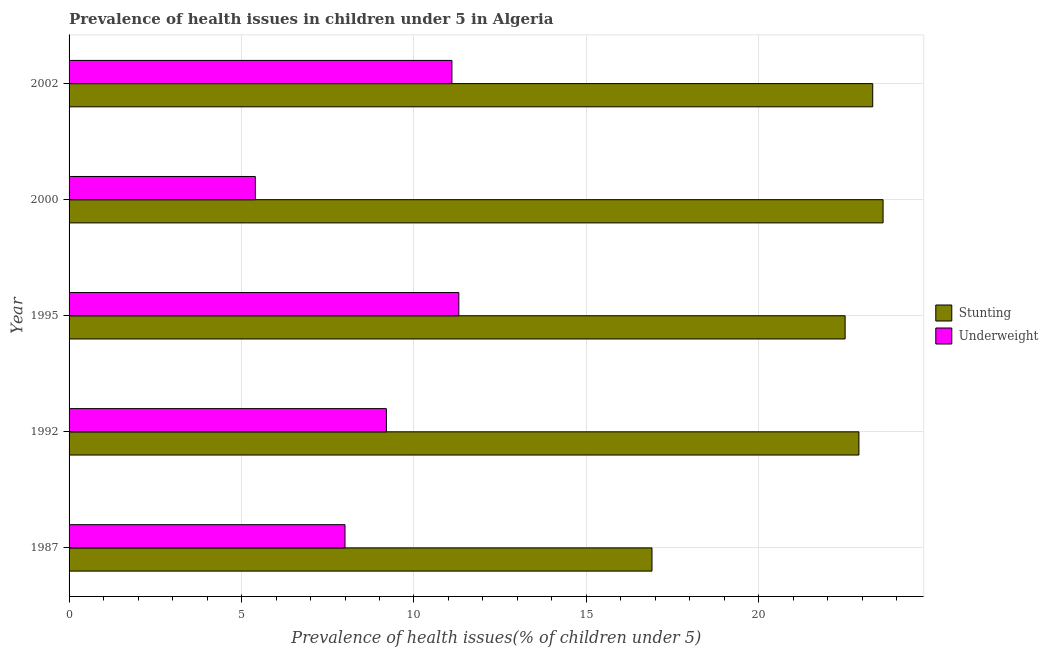How many groups of bars are there?
Keep it short and to the point. 5. Are the number of bars on each tick of the Y-axis equal?
Ensure brevity in your answer.  Yes. How many bars are there on the 1st tick from the top?
Provide a short and direct response. 2. How many bars are there on the 2nd tick from the bottom?
Ensure brevity in your answer.  2. What is the label of the 2nd group of bars from the top?
Your response must be concise. 2000. What is the percentage of stunted children in 2002?
Provide a succinct answer. 23.3. Across all years, what is the maximum percentage of underweight children?
Provide a short and direct response. 11.3. Across all years, what is the minimum percentage of stunted children?
Ensure brevity in your answer.  16.9. In which year was the percentage of stunted children maximum?
Your answer should be very brief. 2000. In which year was the percentage of stunted children minimum?
Provide a succinct answer. 1987. What is the total percentage of underweight children in the graph?
Provide a short and direct response. 45. What is the difference between the percentage of underweight children in 1992 and the percentage of stunted children in 2002?
Offer a very short reply. -14.1. What is the average percentage of underweight children per year?
Your answer should be compact. 9. What is the ratio of the percentage of stunted children in 1987 to that in 2002?
Offer a terse response. 0.72. Is the percentage of underweight children in 1995 less than that in 2002?
Your answer should be compact. No. Is the difference between the percentage of underweight children in 1995 and 2000 greater than the difference between the percentage of stunted children in 1995 and 2000?
Offer a terse response. Yes. What is the difference between the highest and the second highest percentage of stunted children?
Your answer should be very brief. 0.3. In how many years, is the percentage of stunted children greater than the average percentage of stunted children taken over all years?
Keep it short and to the point. 4. Is the sum of the percentage of underweight children in 1987 and 1995 greater than the maximum percentage of stunted children across all years?
Keep it short and to the point. No. What does the 2nd bar from the top in 2000 represents?
Keep it short and to the point. Stunting. What does the 1st bar from the bottom in 2000 represents?
Provide a succinct answer. Stunting. How many bars are there?
Provide a succinct answer. 10. Does the graph contain any zero values?
Offer a terse response. No. Does the graph contain grids?
Your response must be concise. Yes. Where does the legend appear in the graph?
Make the answer very short. Center right. How many legend labels are there?
Ensure brevity in your answer.  2. How are the legend labels stacked?
Give a very brief answer. Vertical. What is the title of the graph?
Make the answer very short. Prevalence of health issues in children under 5 in Algeria. What is the label or title of the X-axis?
Provide a succinct answer. Prevalence of health issues(% of children under 5). What is the label or title of the Y-axis?
Offer a terse response. Year. What is the Prevalence of health issues(% of children under 5) of Stunting in 1987?
Offer a terse response. 16.9. What is the Prevalence of health issues(% of children under 5) of Underweight in 1987?
Your answer should be compact. 8. What is the Prevalence of health issues(% of children under 5) of Stunting in 1992?
Your answer should be very brief. 22.9. What is the Prevalence of health issues(% of children under 5) of Underweight in 1992?
Offer a very short reply. 9.2. What is the Prevalence of health issues(% of children under 5) in Underweight in 1995?
Offer a very short reply. 11.3. What is the Prevalence of health issues(% of children under 5) of Stunting in 2000?
Give a very brief answer. 23.6. What is the Prevalence of health issues(% of children under 5) of Underweight in 2000?
Make the answer very short. 5.4. What is the Prevalence of health issues(% of children under 5) in Stunting in 2002?
Your response must be concise. 23.3. What is the Prevalence of health issues(% of children under 5) in Underweight in 2002?
Provide a short and direct response. 11.1. Across all years, what is the maximum Prevalence of health issues(% of children under 5) in Stunting?
Make the answer very short. 23.6. Across all years, what is the maximum Prevalence of health issues(% of children under 5) of Underweight?
Offer a very short reply. 11.3. Across all years, what is the minimum Prevalence of health issues(% of children under 5) in Stunting?
Your answer should be compact. 16.9. Across all years, what is the minimum Prevalence of health issues(% of children under 5) of Underweight?
Your answer should be compact. 5.4. What is the total Prevalence of health issues(% of children under 5) of Stunting in the graph?
Make the answer very short. 109.2. What is the difference between the Prevalence of health issues(% of children under 5) of Stunting in 1987 and that in 1992?
Provide a short and direct response. -6. What is the difference between the Prevalence of health issues(% of children under 5) in Underweight in 1987 and that in 1995?
Your answer should be compact. -3.3. What is the difference between the Prevalence of health issues(% of children under 5) in Stunting in 1987 and that in 2000?
Make the answer very short. -6.7. What is the difference between the Prevalence of health issues(% of children under 5) of Stunting in 1987 and that in 2002?
Your answer should be very brief. -6.4. What is the difference between the Prevalence of health issues(% of children under 5) of Stunting in 1992 and that in 1995?
Ensure brevity in your answer.  0.4. What is the difference between the Prevalence of health issues(% of children under 5) of Underweight in 1992 and that in 1995?
Your answer should be compact. -2.1. What is the difference between the Prevalence of health issues(% of children under 5) of Stunting in 1992 and that in 2000?
Your answer should be very brief. -0.7. What is the difference between the Prevalence of health issues(% of children under 5) of Underweight in 1992 and that in 2002?
Give a very brief answer. -1.9. What is the difference between the Prevalence of health issues(% of children under 5) in Stunting in 2000 and that in 2002?
Keep it short and to the point. 0.3. What is the difference between the Prevalence of health issues(% of children under 5) in Underweight in 2000 and that in 2002?
Offer a terse response. -5.7. What is the difference between the Prevalence of health issues(% of children under 5) of Stunting in 1987 and the Prevalence of health issues(% of children under 5) of Underweight in 1992?
Keep it short and to the point. 7.7. What is the difference between the Prevalence of health issues(% of children under 5) in Stunting in 1987 and the Prevalence of health issues(% of children under 5) in Underweight in 1995?
Offer a very short reply. 5.6. What is the difference between the Prevalence of health issues(% of children under 5) in Stunting in 1987 and the Prevalence of health issues(% of children under 5) in Underweight in 2000?
Keep it short and to the point. 11.5. What is the difference between the Prevalence of health issues(% of children under 5) of Stunting in 1992 and the Prevalence of health issues(% of children under 5) of Underweight in 1995?
Give a very brief answer. 11.6. What is the difference between the Prevalence of health issues(% of children under 5) in Stunting in 1995 and the Prevalence of health issues(% of children under 5) in Underweight in 2000?
Offer a terse response. 17.1. What is the difference between the Prevalence of health issues(% of children under 5) in Stunting in 1995 and the Prevalence of health issues(% of children under 5) in Underweight in 2002?
Your answer should be compact. 11.4. What is the average Prevalence of health issues(% of children under 5) in Stunting per year?
Your response must be concise. 21.84. What is the average Prevalence of health issues(% of children under 5) in Underweight per year?
Ensure brevity in your answer.  9. In the year 1987, what is the difference between the Prevalence of health issues(% of children under 5) of Stunting and Prevalence of health issues(% of children under 5) of Underweight?
Provide a short and direct response. 8.9. What is the ratio of the Prevalence of health issues(% of children under 5) of Stunting in 1987 to that in 1992?
Offer a very short reply. 0.74. What is the ratio of the Prevalence of health issues(% of children under 5) in Underweight in 1987 to that in 1992?
Give a very brief answer. 0.87. What is the ratio of the Prevalence of health issues(% of children under 5) of Stunting in 1987 to that in 1995?
Provide a short and direct response. 0.75. What is the ratio of the Prevalence of health issues(% of children under 5) of Underweight in 1987 to that in 1995?
Offer a terse response. 0.71. What is the ratio of the Prevalence of health issues(% of children under 5) in Stunting in 1987 to that in 2000?
Offer a very short reply. 0.72. What is the ratio of the Prevalence of health issues(% of children under 5) in Underweight in 1987 to that in 2000?
Provide a succinct answer. 1.48. What is the ratio of the Prevalence of health issues(% of children under 5) in Stunting in 1987 to that in 2002?
Offer a very short reply. 0.73. What is the ratio of the Prevalence of health issues(% of children under 5) of Underweight in 1987 to that in 2002?
Ensure brevity in your answer.  0.72. What is the ratio of the Prevalence of health issues(% of children under 5) of Stunting in 1992 to that in 1995?
Provide a short and direct response. 1.02. What is the ratio of the Prevalence of health issues(% of children under 5) of Underweight in 1992 to that in 1995?
Provide a short and direct response. 0.81. What is the ratio of the Prevalence of health issues(% of children under 5) of Stunting in 1992 to that in 2000?
Offer a terse response. 0.97. What is the ratio of the Prevalence of health issues(% of children under 5) of Underweight in 1992 to that in 2000?
Ensure brevity in your answer.  1.7. What is the ratio of the Prevalence of health issues(% of children under 5) in Stunting in 1992 to that in 2002?
Provide a succinct answer. 0.98. What is the ratio of the Prevalence of health issues(% of children under 5) of Underweight in 1992 to that in 2002?
Your answer should be very brief. 0.83. What is the ratio of the Prevalence of health issues(% of children under 5) of Stunting in 1995 to that in 2000?
Your answer should be compact. 0.95. What is the ratio of the Prevalence of health issues(% of children under 5) of Underweight in 1995 to that in 2000?
Your response must be concise. 2.09. What is the ratio of the Prevalence of health issues(% of children under 5) in Stunting in 1995 to that in 2002?
Provide a short and direct response. 0.97. What is the ratio of the Prevalence of health issues(% of children under 5) of Underweight in 1995 to that in 2002?
Your answer should be very brief. 1.02. What is the ratio of the Prevalence of health issues(% of children under 5) in Stunting in 2000 to that in 2002?
Provide a short and direct response. 1.01. What is the ratio of the Prevalence of health issues(% of children under 5) of Underweight in 2000 to that in 2002?
Make the answer very short. 0.49. What is the difference between the highest and the second highest Prevalence of health issues(% of children under 5) of Stunting?
Ensure brevity in your answer.  0.3. 